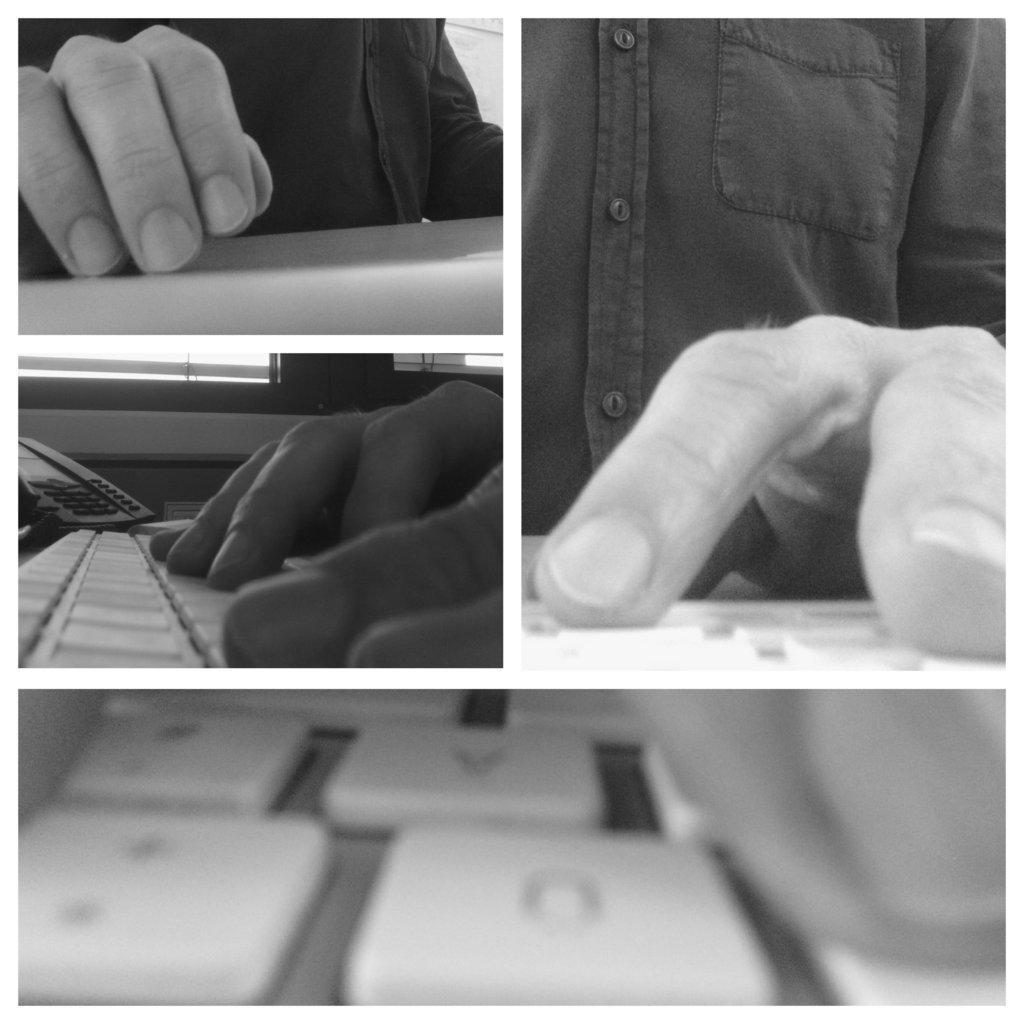Can you describe this image briefly? This is a collage image of a person using the keyboard. 